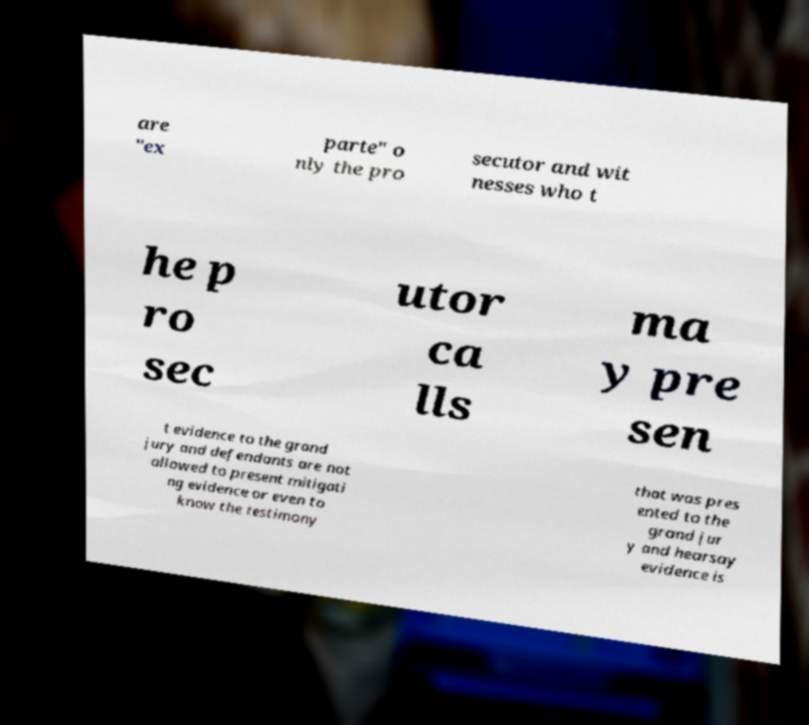Could you assist in decoding the text presented in this image and type it out clearly? are "ex parte" o nly the pro secutor and wit nesses who t he p ro sec utor ca lls ma y pre sen t evidence to the grand jury and defendants are not allowed to present mitigati ng evidence or even to know the testimony that was pres ented to the grand jur y and hearsay evidence is 